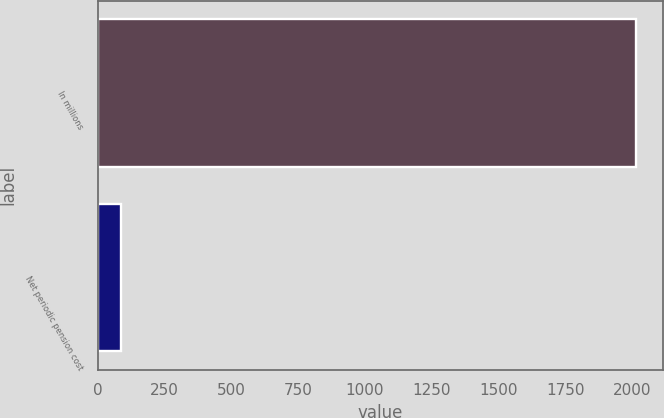Convert chart to OTSL. <chart><loc_0><loc_0><loc_500><loc_500><bar_chart><fcel>In millions<fcel>Net periodic pension cost<nl><fcel>2013<fcel>87<nl></chart> 